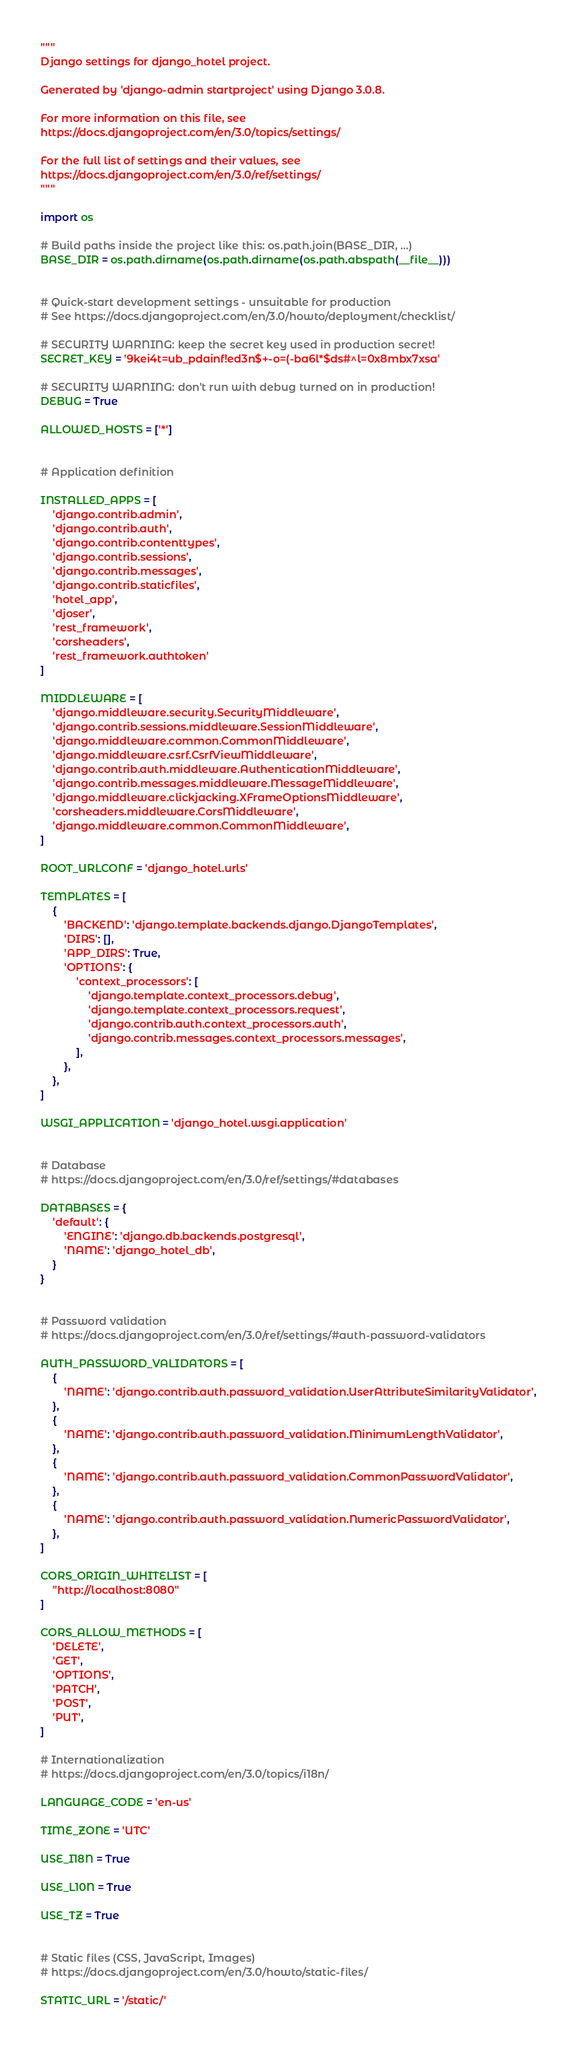Convert code to text. <code><loc_0><loc_0><loc_500><loc_500><_Python_>"""
Django settings for django_hotel project.

Generated by 'django-admin startproject' using Django 3.0.8.

For more information on this file, see
https://docs.djangoproject.com/en/3.0/topics/settings/

For the full list of settings and their values, see
https://docs.djangoproject.com/en/3.0/ref/settings/
"""

import os

# Build paths inside the project like this: os.path.join(BASE_DIR, ...)
BASE_DIR = os.path.dirname(os.path.dirname(os.path.abspath(__file__)))


# Quick-start development settings - unsuitable for production
# See https://docs.djangoproject.com/en/3.0/howto/deployment/checklist/

# SECURITY WARNING: keep the secret key used in production secret!
SECRET_KEY = '9kei4t=ub_pdainf!ed3n$+-o=(-ba6l*$ds#^l=0x8mbx7xsa'

# SECURITY WARNING: don't run with debug turned on in production!
DEBUG = True

ALLOWED_HOSTS = ['*']


# Application definition

INSTALLED_APPS = [
    'django.contrib.admin',
    'django.contrib.auth',
    'django.contrib.contenttypes',
    'django.contrib.sessions',
    'django.contrib.messages',
    'django.contrib.staticfiles',
    'hotel_app',
    'djoser',
    'rest_framework',
    'corsheaders',
    'rest_framework.authtoken'
]

MIDDLEWARE = [
    'django.middleware.security.SecurityMiddleware',
    'django.contrib.sessions.middleware.SessionMiddleware',
    'django.middleware.common.CommonMiddleware',
    'django.middleware.csrf.CsrfViewMiddleware',
    'django.contrib.auth.middleware.AuthenticationMiddleware',
    'django.contrib.messages.middleware.MessageMiddleware',
    'django.middleware.clickjacking.XFrameOptionsMiddleware',
    'corsheaders.middleware.CorsMiddleware',
    'django.middleware.common.CommonMiddleware',
]

ROOT_URLCONF = 'django_hotel.urls'

TEMPLATES = [
    {
        'BACKEND': 'django.template.backends.django.DjangoTemplates',
        'DIRS': [],
        'APP_DIRS': True,
        'OPTIONS': {
            'context_processors': [
                'django.template.context_processors.debug',
                'django.template.context_processors.request',
                'django.contrib.auth.context_processors.auth',
                'django.contrib.messages.context_processors.messages',
            ],
        },
    },
]

WSGI_APPLICATION = 'django_hotel.wsgi.application'


# Database
# https://docs.djangoproject.com/en/3.0/ref/settings/#databases

DATABASES = {
    'default': {
        'ENGINE': 'django.db.backends.postgresql',
        'NAME': 'django_hotel_db',
    }
}


# Password validation
# https://docs.djangoproject.com/en/3.0/ref/settings/#auth-password-validators

AUTH_PASSWORD_VALIDATORS = [
    {
        'NAME': 'django.contrib.auth.password_validation.UserAttributeSimilarityValidator',
    },
    {
        'NAME': 'django.contrib.auth.password_validation.MinimumLengthValidator',
    },
    {
        'NAME': 'django.contrib.auth.password_validation.CommonPasswordValidator',
    },
    {
        'NAME': 'django.contrib.auth.password_validation.NumericPasswordValidator',
    },
]

CORS_ORIGIN_WHITELIST = [
    "http://localhost:8080"
]

CORS_ALLOW_METHODS = [
    'DELETE',
    'GET',
    'OPTIONS',
    'PATCH',
    'POST',
    'PUT',
]

# Internationalization
# https://docs.djangoproject.com/en/3.0/topics/i18n/

LANGUAGE_CODE = 'en-us'

TIME_ZONE = 'UTC'

USE_I18N = True

USE_L10N = True

USE_TZ = True


# Static files (CSS, JavaScript, Images)
# https://docs.djangoproject.com/en/3.0/howto/static-files/

STATIC_URL = '/static/'
</code> 